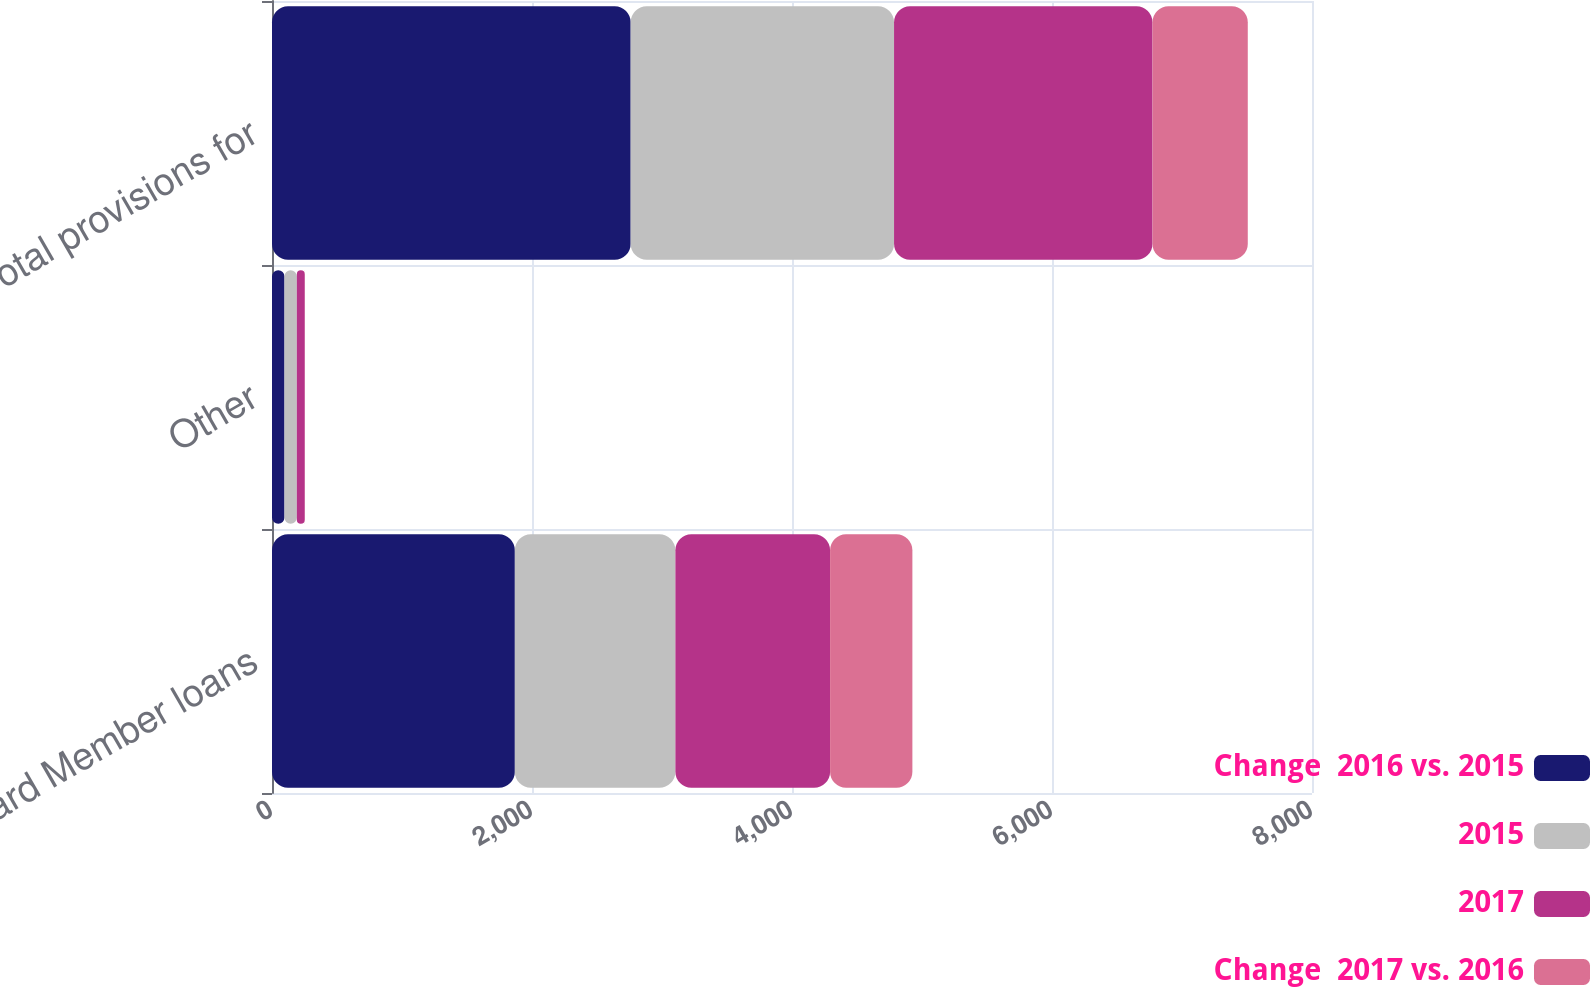Convert chart to OTSL. <chart><loc_0><loc_0><loc_500><loc_500><stacked_bar_chart><ecel><fcel>Card Member loans<fcel>Other<fcel>Total provisions for<nl><fcel>Change  2016 vs. 2015<fcel>1868<fcel>96<fcel>2759<nl><fcel>2015<fcel>1235<fcel>95<fcel>2026<nl><fcel>2017<fcel>1190<fcel>61<fcel>1988<nl><fcel>Change  2017 vs. 2016<fcel>633<fcel>1<fcel>733<nl></chart> 